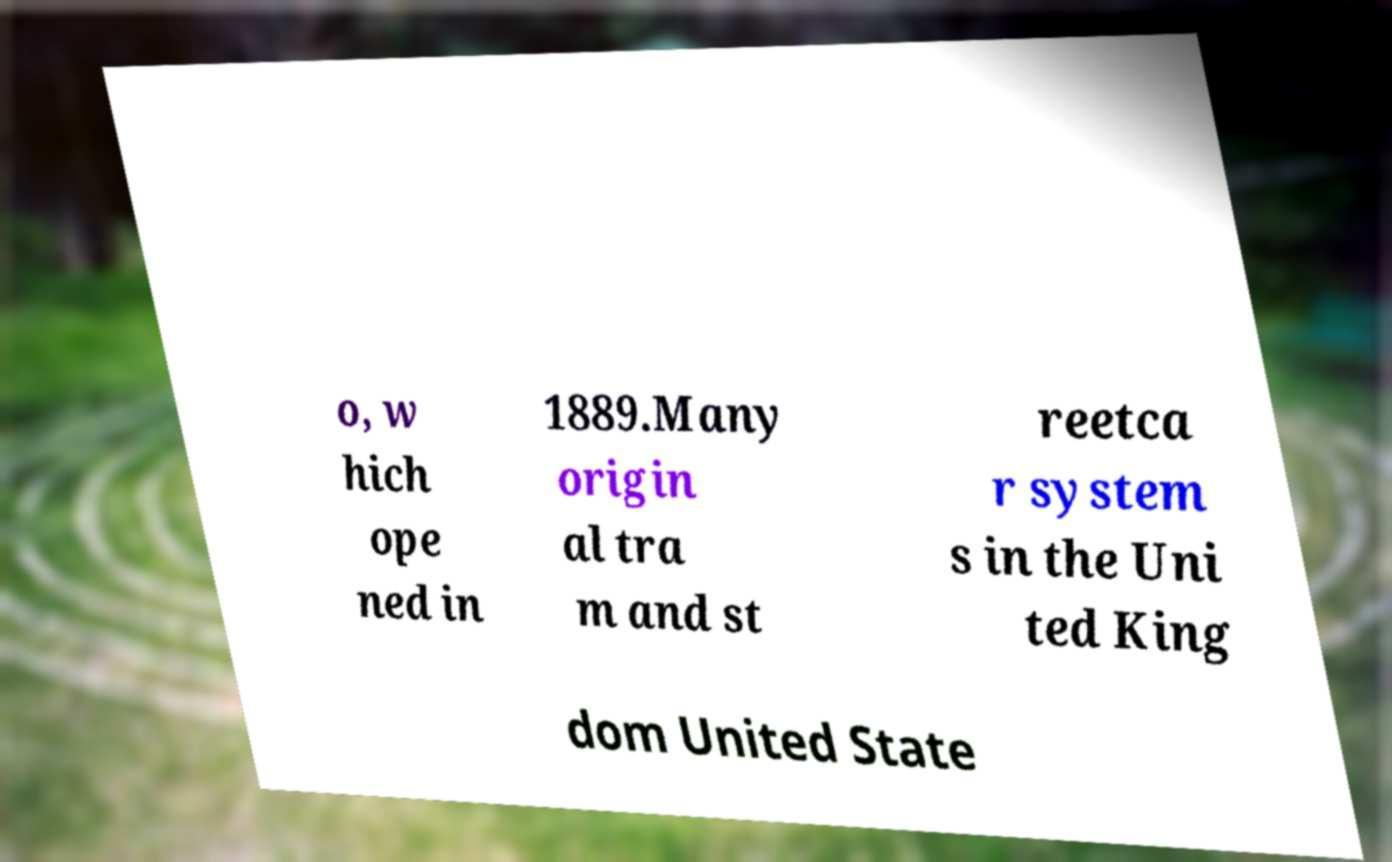Please read and relay the text visible in this image. What does it say? o, w hich ope ned in 1889.Many origin al tra m and st reetca r system s in the Uni ted King dom United State 